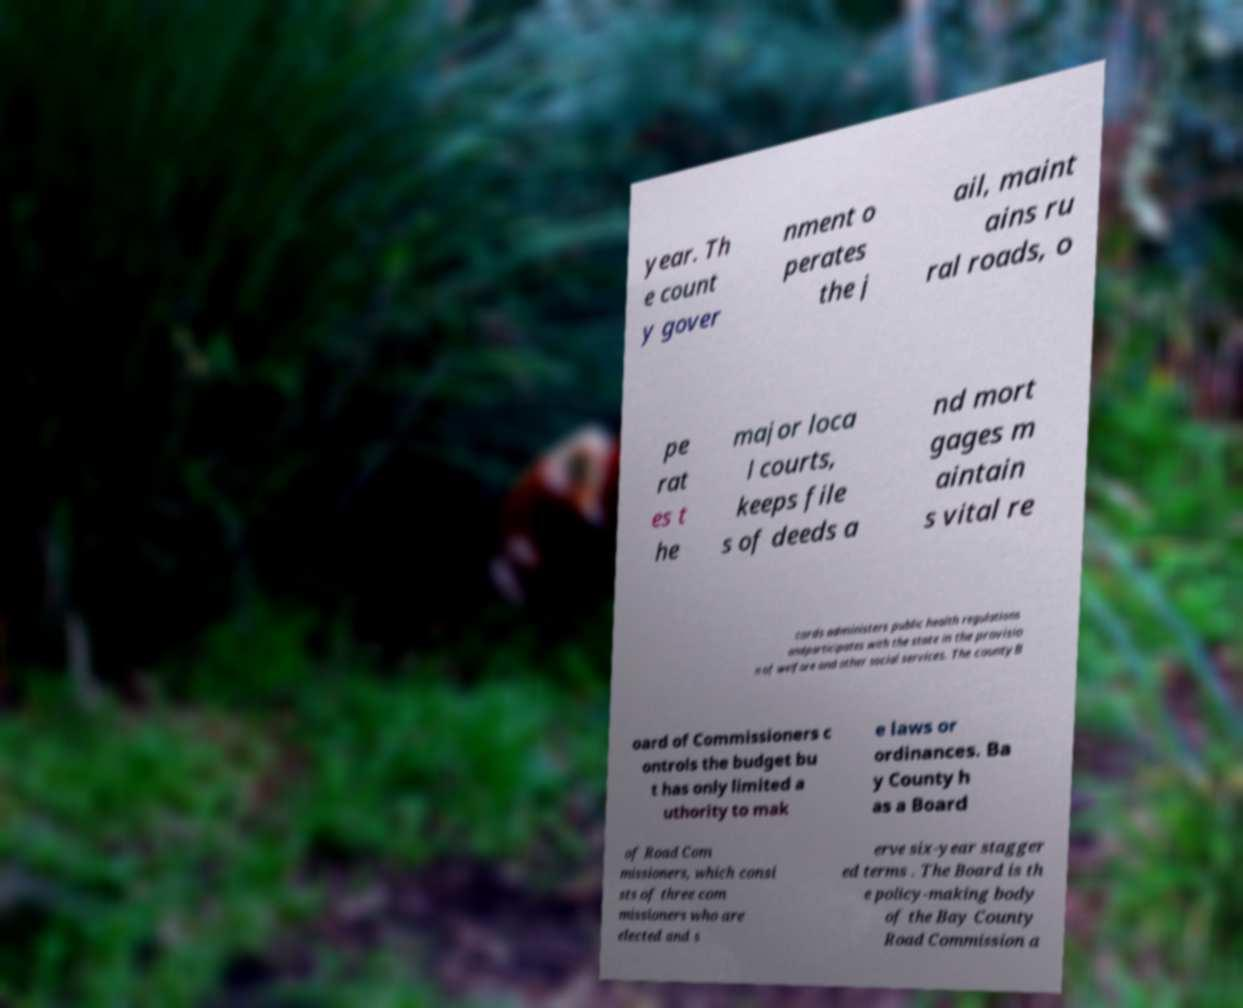Could you extract and type out the text from this image? year. Th e count y gover nment o perates the j ail, maint ains ru ral roads, o pe rat es t he major loca l courts, keeps file s of deeds a nd mort gages m aintain s vital re cords administers public health regulations andparticipates with the state in the provisio n of welfare and other social services. The countyB oard of Commissioners c ontrols the budget bu t has only limited a uthority to mak e laws or ordinances. Ba y County h as a Board of Road Com missioners, which consi sts of three com missioners who are elected and s erve six-year stagger ed terms . The Board is th e policy-making body of the Bay County Road Commission a 